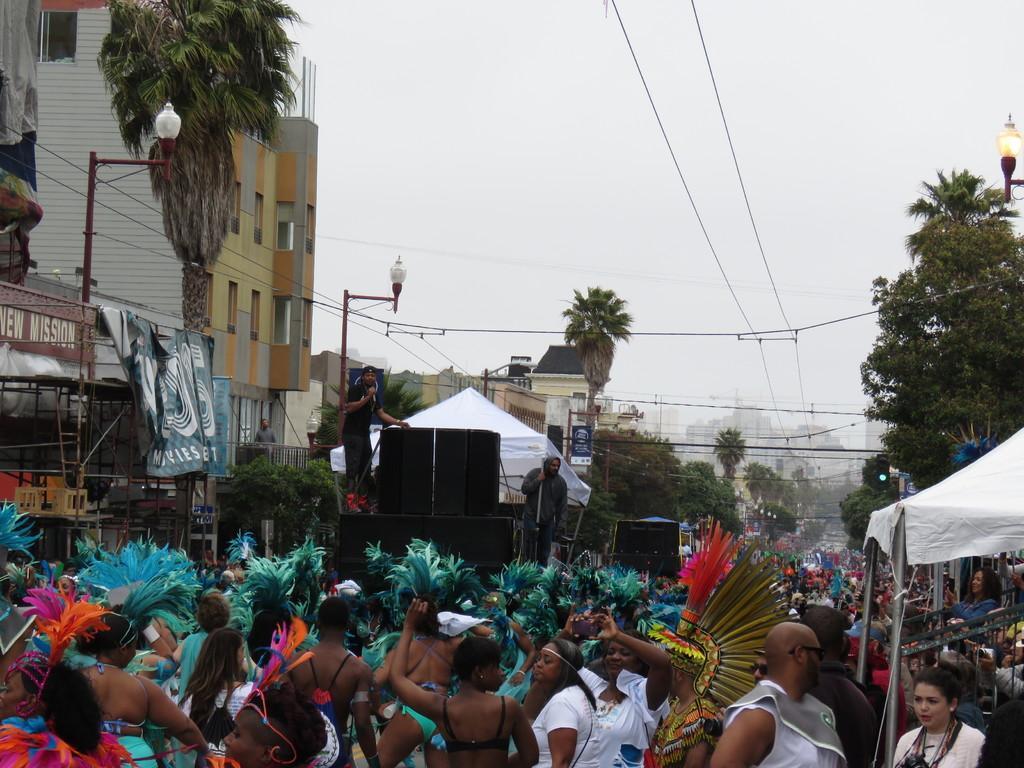How would you summarize this image in a sentence or two? In this image I can see number of people are standing. I can also see everyone are wearing costumes. On the right side and on the left side of this image I can see number of trees, lights, wires and few white colour clothes. On the left side of this image I can see number of buildings, few boards and on these words I can see something is written. 